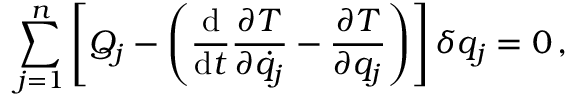<formula> <loc_0><loc_0><loc_500><loc_500>\sum _ { j = 1 } ^ { n } \left [ Q _ { j } - \left ( { \frac { d } { d t } } { \frac { \partial T } { \partial { \dot { q } } _ { j } } } - { \frac { \partial T } { \partial q _ { j } } } \right ) \right ] \delta q _ { j } = 0 \, ,</formula> 